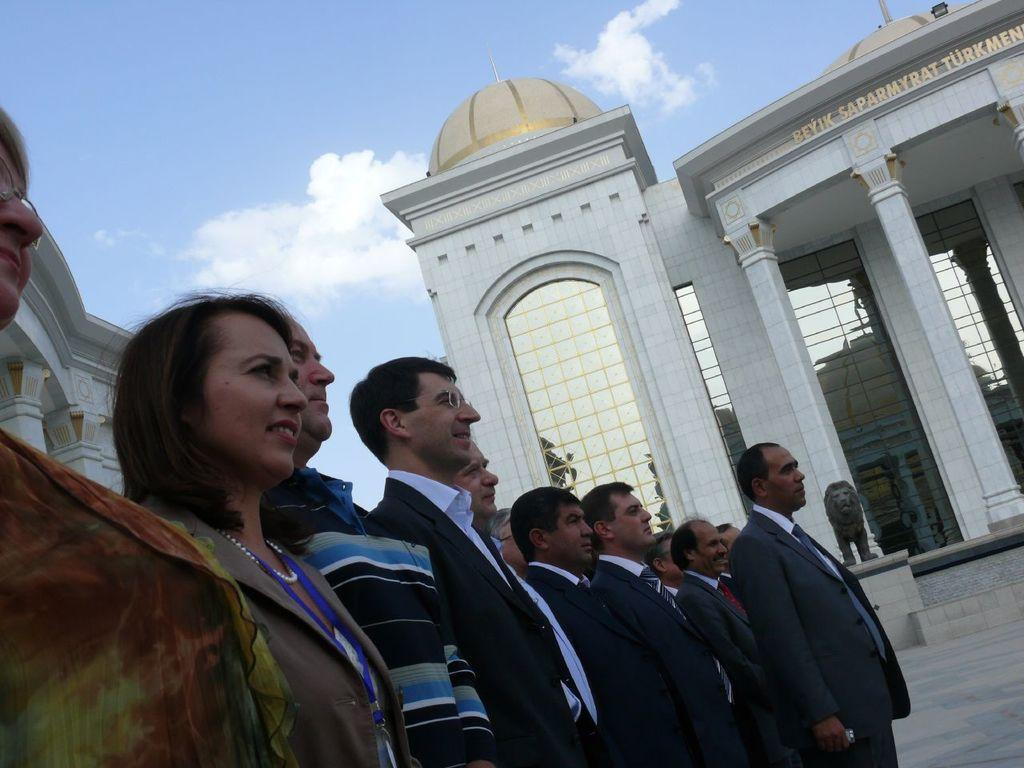What is happening in the image? There are people standing in the image. Can you describe the attire of the people? The people are wearing different color dresses. What type of structures can be seen in the image? There are buildings in the image, and pillars are present as well. Is there any artwork or sculpture in the image? Yes, there is a statue in the image. What is the color of the sky in the image? The sky is blue and white in color. What type of canvas is being used by the achiever in the image? There is no mention of an achiever or a canvas in the image. The image features people standing, buildings, pillars, a statue, and a blue and white sky. 